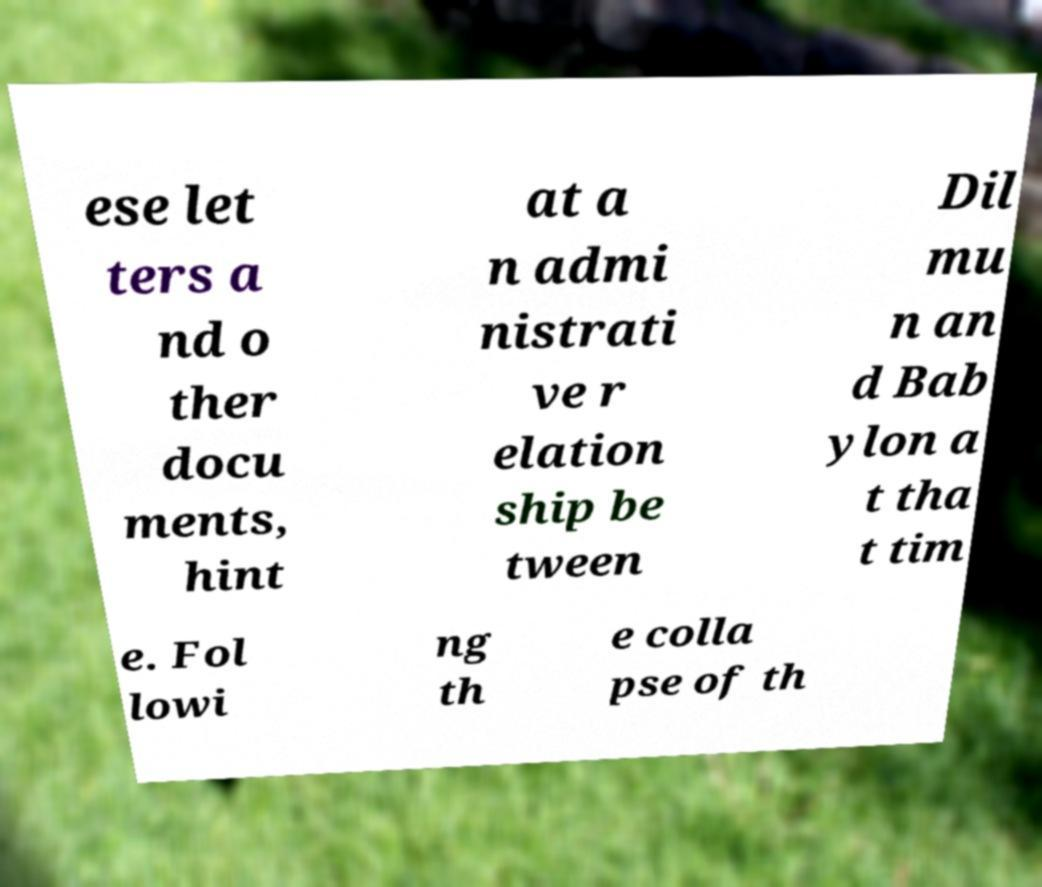Please read and relay the text visible in this image. What does it say? ese let ters a nd o ther docu ments, hint at a n admi nistrati ve r elation ship be tween Dil mu n an d Bab ylon a t tha t tim e. Fol lowi ng th e colla pse of th 